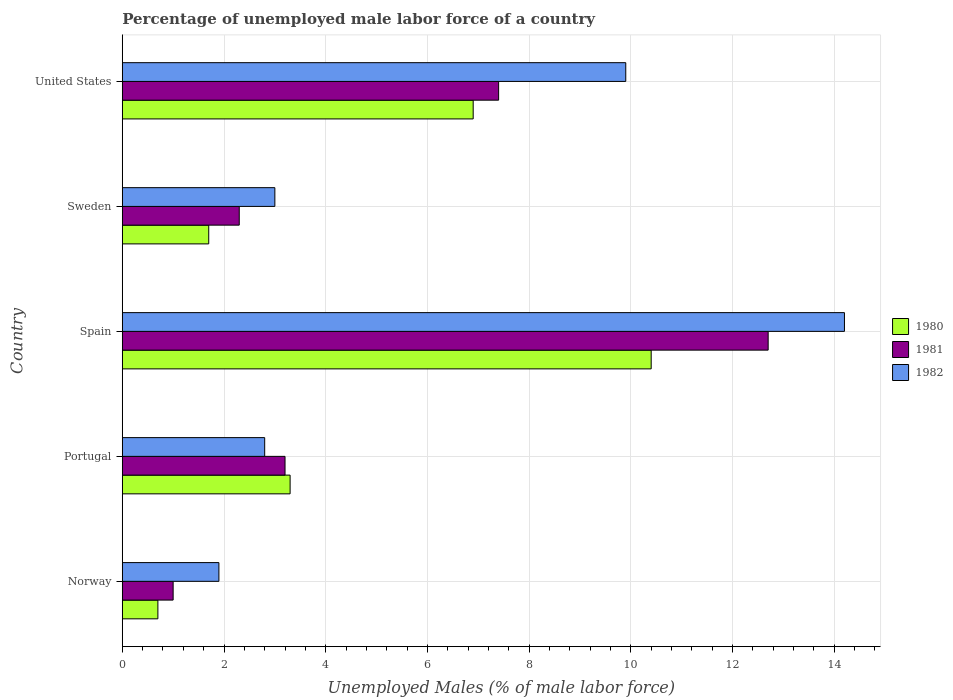How many different coloured bars are there?
Offer a very short reply. 3. How many groups of bars are there?
Your answer should be compact. 5. How many bars are there on the 4th tick from the top?
Your answer should be compact. 3. What is the label of the 1st group of bars from the top?
Offer a terse response. United States. What is the percentage of unemployed male labor force in 1982 in Norway?
Keep it short and to the point. 1.9. Across all countries, what is the maximum percentage of unemployed male labor force in 1982?
Your answer should be very brief. 14.2. Across all countries, what is the minimum percentage of unemployed male labor force in 1982?
Your answer should be very brief. 1.9. What is the total percentage of unemployed male labor force in 1982 in the graph?
Provide a short and direct response. 31.8. What is the difference between the percentage of unemployed male labor force in 1980 in Sweden and that in United States?
Ensure brevity in your answer.  -5.2. What is the difference between the percentage of unemployed male labor force in 1981 in Norway and the percentage of unemployed male labor force in 1980 in United States?
Your answer should be very brief. -5.9. What is the average percentage of unemployed male labor force in 1980 per country?
Your answer should be compact. 4.6. What is the difference between the percentage of unemployed male labor force in 1981 and percentage of unemployed male labor force in 1982 in United States?
Keep it short and to the point. -2.5. What is the ratio of the percentage of unemployed male labor force in 1980 in Sweden to that in United States?
Provide a short and direct response. 0.25. Is the difference between the percentage of unemployed male labor force in 1981 in Sweden and United States greater than the difference between the percentage of unemployed male labor force in 1982 in Sweden and United States?
Make the answer very short. Yes. What is the difference between the highest and the second highest percentage of unemployed male labor force in 1982?
Offer a very short reply. 4.3. What is the difference between the highest and the lowest percentage of unemployed male labor force in 1982?
Keep it short and to the point. 12.3. How many bars are there?
Your answer should be very brief. 15. How many countries are there in the graph?
Offer a very short reply. 5. What is the difference between two consecutive major ticks on the X-axis?
Your response must be concise. 2. Does the graph contain any zero values?
Provide a short and direct response. No. Does the graph contain grids?
Ensure brevity in your answer.  Yes. What is the title of the graph?
Your response must be concise. Percentage of unemployed male labor force of a country. Does "1994" appear as one of the legend labels in the graph?
Give a very brief answer. No. What is the label or title of the X-axis?
Give a very brief answer. Unemployed Males (% of male labor force). What is the Unemployed Males (% of male labor force) of 1980 in Norway?
Give a very brief answer. 0.7. What is the Unemployed Males (% of male labor force) of 1981 in Norway?
Provide a succinct answer. 1. What is the Unemployed Males (% of male labor force) in 1982 in Norway?
Your answer should be very brief. 1.9. What is the Unemployed Males (% of male labor force) in 1980 in Portugal?
Give a very brief answer. 3.3. What is the Unemployed Males (% of male labor force) in 1981 in Portugal?
Make the answer very short. 3.2. What is the Unemployed Males (% of male labor force) in 1982 in Portugal?
Provide a succinct answer. 2.8. What is the Unemployed Males (% of male labor force) of 1980 in Spain?
Keep it short and to the point. 10.4. What is the Unemployed Males (% of male labor force) in 1981 in Spain?
Make the answer very short. 12.7. What is the Unemployed Males (% of male labor force) in 1982 in Spain?
Provide a short and direct response. 14.2. What is the Unemployed Males (% of male labor force) of 1980 in Sweden?
Provide a succinct answer. 1.7. What is the Unemployed Males (% of male labor force) of 1981 in Sweden?
Offer a very short reply. 2.3. What is the Unemployed Males (% of male labor force) in 1982 in Sweden?
Keep it short and to the point. 3. What is the Unemployed Males (% of male labor force) of 1980 in United States?
Give a very brief answer. 6.9. What is the Unemployed Males (% of male labor force) in 1981 in United States?
Your answer should be very brief. 7.4. What is the Unemployed Males (% of male labor force) in 1982 in United States?
Your response must be concise. 9.9. Across all countries, what is the maximum Unemployed Males (% of male labor force) in 1980?
Make the answer very short. 10.4. Across all countries, what is the maximum Unemployed Males (% of male labor force) of 1981?
Offer a very short reply. 12.7. Across all countries, what is the maximum Unemployed Males (% of male labor force) in 1982?
Keep it short and to the point. 14.2. Across all countries, what is the minimum Unemployed Males (% of male labor force) of 1980?
Offer a terse response. 0.7. Across all countries, what is the minimum Unemployed Males (% of male labor force) in 1982?
Provide a succinct answer. 1.9. What is the total Unemployed Males (% of male labor force) in 1981 in the graph?
Provide a short and direct response. 26.6. What is the total Unemployed Males (% of male labor force) in 1982 in the graph?
Provide a short and direct response. 31.8. What is the difference between the Unemployed Males (% of male labor force) of 1982 in Norway and that in Portugal?
Your answer should be compact. -0.9. What is the difference between the Unemployed Males (% of male labor force) of 1980 in Norway and that in Spain?
Keep it short and to the point. -9.7. What is the difference between the Unemployed Males (% of male labor force) in 1981 in Norway and that in Spain?
Your response must be concise. -11.7. What is the difference between the Unemployed Males (% of male labor force) of 1982 in Norway and that in Spain?
Your answer should be very brief. -12.3. What is the difference between the Unemployed Males (% of male labor force) in 1981 in Norway and that in Sweden?
Your response must be concise. -1.3. What is the difference between the Unemployed Males (% of male labor force) in 1982 in Norway and that in Sweden?
Keep it short and to the point. -1.1. What is the difference between the Unemployed Males (% of male labor force) in 1980 in Norway and that in United States?
Your answer should be very brief. -6.2. What is the difference between the Unemployed Males (% of male labor force) of 1982 in Portugal and that in Spain?
Your answer should be compact. -11.4. What is the difference between the Unemployed Males (% of male labor force) of 1981 in Portugal and that in Sweden?
Your response must be concise. 0.9. What is the difference between the Unemployed Males (% of male labor force) of 1980 in Portugal and that in United States?
Your answer should be compact. -3.6. What is the difference between the Unemployed Males (% of male labor force) of 1981 in Portugal and that in United States?
Your answer should be very brief. -4.2. What is the difference between the Unemployed Males (% of male labor force) in 1982 in Portugal and that in United States?
Keep it short and to the point. -7.1. What is the difference between the Unemployed Males (% of male labor force) of 1981 in Spain and that in Sweden?
Your answer should be compact. 10.4. What is the difference between the Unemployed Males (% of male labor force) of 1981 in Spain and that in United States?
Your answer should be very brief. 5.3. What is the difference between the Unemployed Males (% of male labor force) in 1980 in Sweden and that in United States?
Keep it short and to the point. -5.2. What is the difference between the Unemployed Males (% of male labor force) in 1982 in Sweden and that in United States?
Your answer should be very brief. -6.9. What is the difference between the Unemployed Males (% of male labor force) in 1980 in Norway and the Unemployed Males (% of male labor force) in 1981 in Portugal?
Your response must be concise. -2.5. What is the difference between the Unemployed Males (% of male labor force) in 1980 in Norway and the Unemployed Males (% of male labor force) in 1982 in Spain?
Give a very brief answer. -13.5. What is the difference between the Unemployed Males (% of male labor force) in 1981 in Norway and the Unemployed Males (% of male labor force) in 1982 in Spain?
Your answer should be compact. -13.2. What is the difference between the Unemployed Males (% of male labor force) in 1980 in Portugal and the Unemployed Males (% of male labor force) in 1982 in Sweden?
Your answer should be compact. 0.3. What is the difference between the Unemployed Males (% of male labor force) in 1981 in Portugal and the Unemployed Males (% of male labor force) in 1982 in Sweden?
Offer a terse response. 0.2. What is the difference between the Unemployed Males (% of male labor force) of 1981 in Spain and the Unemployed Males (% of male labor force) of 1982 in Sweden?
Your answer should be very brief. 9.7. What is the difference between the Unemployed Males (% of male labor force) of 1980 in Spain and the Unemployed Males (% of male labor force) of 1981 in United States?
Keep it short and to the point. 3. What is the difference between the Unemployed Males (% of male labor force) of 1980 in Sweden and the Unemployed Males (% of male labor force) of 1981 in United States?
Make the answer very short. -5.7. What is the difference between the Unemployed Males (% of male labor force) of 1980 in Sweden and the Unemployed Males (% of male labor force) of 1982 in United States?
Offer a terse response. -8.2. What is the average Unemployed Males (% of male labor force) in 1981 per country?
Ensure brevity in your answer.  5.32. What is the average Unemployed Males (% of male labor force) in 1982 per country?
Your answer should be compact. 6.36. What is the difference between the Unemployed Males (% of male labor force) in 1980 and Unemployed Males (% of male labor force) in 1982 in Norway?
Your answer should be very brief. -1.2. What is the difference between the Unemployed Males (% of male labor force) of 1981 and Unemployed Males (% of male labor force) of 1982 in Portugal?
Your response must be concise. 0.4. What is the difference between the Unemployed Males (% of male labor force) of 1980 and Unemployed Males (% of male labor force) of 1982 in Spain?
Keep it short and to the point. -3.8. What is the difference between the Unemployed Males (% of male labor force) in 1981 and Unemployed Males (% of male labor force) in 1982 in Spain?
Ensure brevity in your answer.  -1.5. What is the difference between the Unemployed Males (% of male labor force) of 1980 and Unemployed Males (% of male labor force) of 1981 in Sweden?
Your response must be concise. -0.6. What is the difference between the Unemployed Males (% of male labor force) of 1980 and Unemployed Males (% of male labor force) of 1982 in Sweden?
Your answer should be very brief. -1.3. What is the difference between the Unemployed Males (% of male labor force) of 1981 and Unemployed Males (% of male labor force) of 1982 in Sweden?
Provide a succinct answer. -0.7. What is the difference between the Unemployed Males (% of male labor force) in 1980 and Unemployed Males (% of male labor force) in 1981 in United States?
Provide a succinct answer. -0.5. What is the difference between the Unemployed Males (% of male labor force) of 1981 and Unemployed Males (% of male labor force) of 1982 in United States?
Your response must be concise. -2.5. What is the ratio of the Unemployed Males (% of male labor force) of 1980 in Norway to that in Portugal?
Provide a short and direct response. 0.21. What is the ratio of the Unemployed Males (% of male labor force) in 1981 in Norway to that in Portugal?
Offer a very short reply. 0.31. What is the ratio of the Unemployed Males (% of male labor force) of 1982 in Norway to that in Portugal?
Ensure brevity in your answer.  0.68. What is the ratio of the Unemployed Males (% of male labor force) in 1980 in Norway to that in Spain?
Provide a short and direct response. 0.07. What is the ratio of the Unemployed Males (% of male labor force) in 1981 in Norway to that in Spain?
Give a very brief answer. 0.08. What is the ratio of the Unemployed Males (% of male labor force) in 1982 in Norway to that in Spain?
Offer a very short reply. 0.13. What is the ratio of the Unemployed Males (% of male labor force) in 1980 in Norway to that in Sweden?
Offer a terse response. 0.41. What is the ratio of the Unemployed Males (% of male labor force) of 1981 in Norway to that in Sweden?
Provide a succinct answer. 0.43. What is the ratio of the Unemployed Males (% of male labor force) of 1982 in Norway to that in Sweden?
Provide a short and direct response. 0.63. What is the ratio of the Unemployed Males (% of male labor force) of 1980 in Norway to that in United States?
Keep it short and to the point. 0.1. What is the ratio of the Unemployed Males (% of male labor force) in 1981 in Norway to that in United States?
Provide a short and direct response. 0.14. What is the ratio of the Unemployed Males (% of male labor force) in 1982 in Norway to that in United States?
Your answer should be very brief. 0.19. What is the ratio of the Unemployed Males (% of male labor force) of 1980 in Portugal to that in Spain?
Your answer should be compact. 0.32. What is the ratio of the Unemployed Males (% of male labor force) of 1981 in Portugal to that in Spain?
Your answer should be compact. 0.25. What is the ratio of the Unemployed Males (% of male labor force) in 1982 in Portugal to that in Spain?
Ensure brevity in your answer.  0.2. What is the ratio of the Unemployed Males (% of male labor force) of 1980 in Portugal to that in Sweden?
Provide a short and direct response. 1.94. What is the ratio of the Unemployed Males (% of male labor force) in 1981 in Portugal to that in Sweden?
Provide a succinct answer. 1.39. What is the ratio of the Unemployed Males (% of male labor force) of 1982 in Portugal to that in Sweden?
Offer a terse response. 0.93. What is the ratio of the Unemployed Males (% of male labor force) of 1980 in Portugal to that in United States?
Your response must be concise. 0.48. What is the ratio of the Unemployed Males (% of male labor force) of 1981 in Portugal to that in United States?
Provide a short and direct response. 0.43. What is the ratio of the Unemployed Males (% of male labor force) of 1982 in Portugal to that in United States?
Give a very brief answer. 0.28. What is the ratio of the Unemployed Males (% of male labor force) of 1980 in Spain to that in Sweden?
Offer a very short reply. 6.12. What is the ratio of the Unemployed Males (% of male labor force) of 1981 in Spain to that in Sweden?
Provide a succinct answer. 5.52. What is the ratio of the Unemployed Males (% of male labor force) in 1982 in Spain to that in Sweden?
Provide a succinct answer. 4.73. What is the ratio of the Unemployed Males (% of male labor force) of 1980 in Spain to that in United States?
Your answer should be very brief. 1.51. What is the ratio of the Unemployed Males (% of male labor force) in 1981 in Spain to that in United States?
Provide a succinct answer. 1.72. What is the ratio of the Unemployed Males (% of male labor force) of 1982 in Spain to that in United States?
Give a very brief answer. 1.43. What is the ratio of the Unemployed Males (% of male labor force) in 1980 in Sweden to that in United States?
Offer a terse response. 0.25. What is the ratio of the Unemployed Males (% of male labor force) in 1981 in Sweden to that in United States?
Provide a short and direct response. 0.31. What is the ratio of the Unemployed Males (% of male labor force) in 1982 in Sweden to that in United States?
Keep it short and to the point. 0.3. What is the difference between the highest and the second highest Unemployed Males (% of male labor force) in 1982?
Keep it short and to the point. 4.3. What is the difference between the highest and the lowest Unemployed Males (% of male labor force) in 1982?
Offer a terse response. 12.3. 